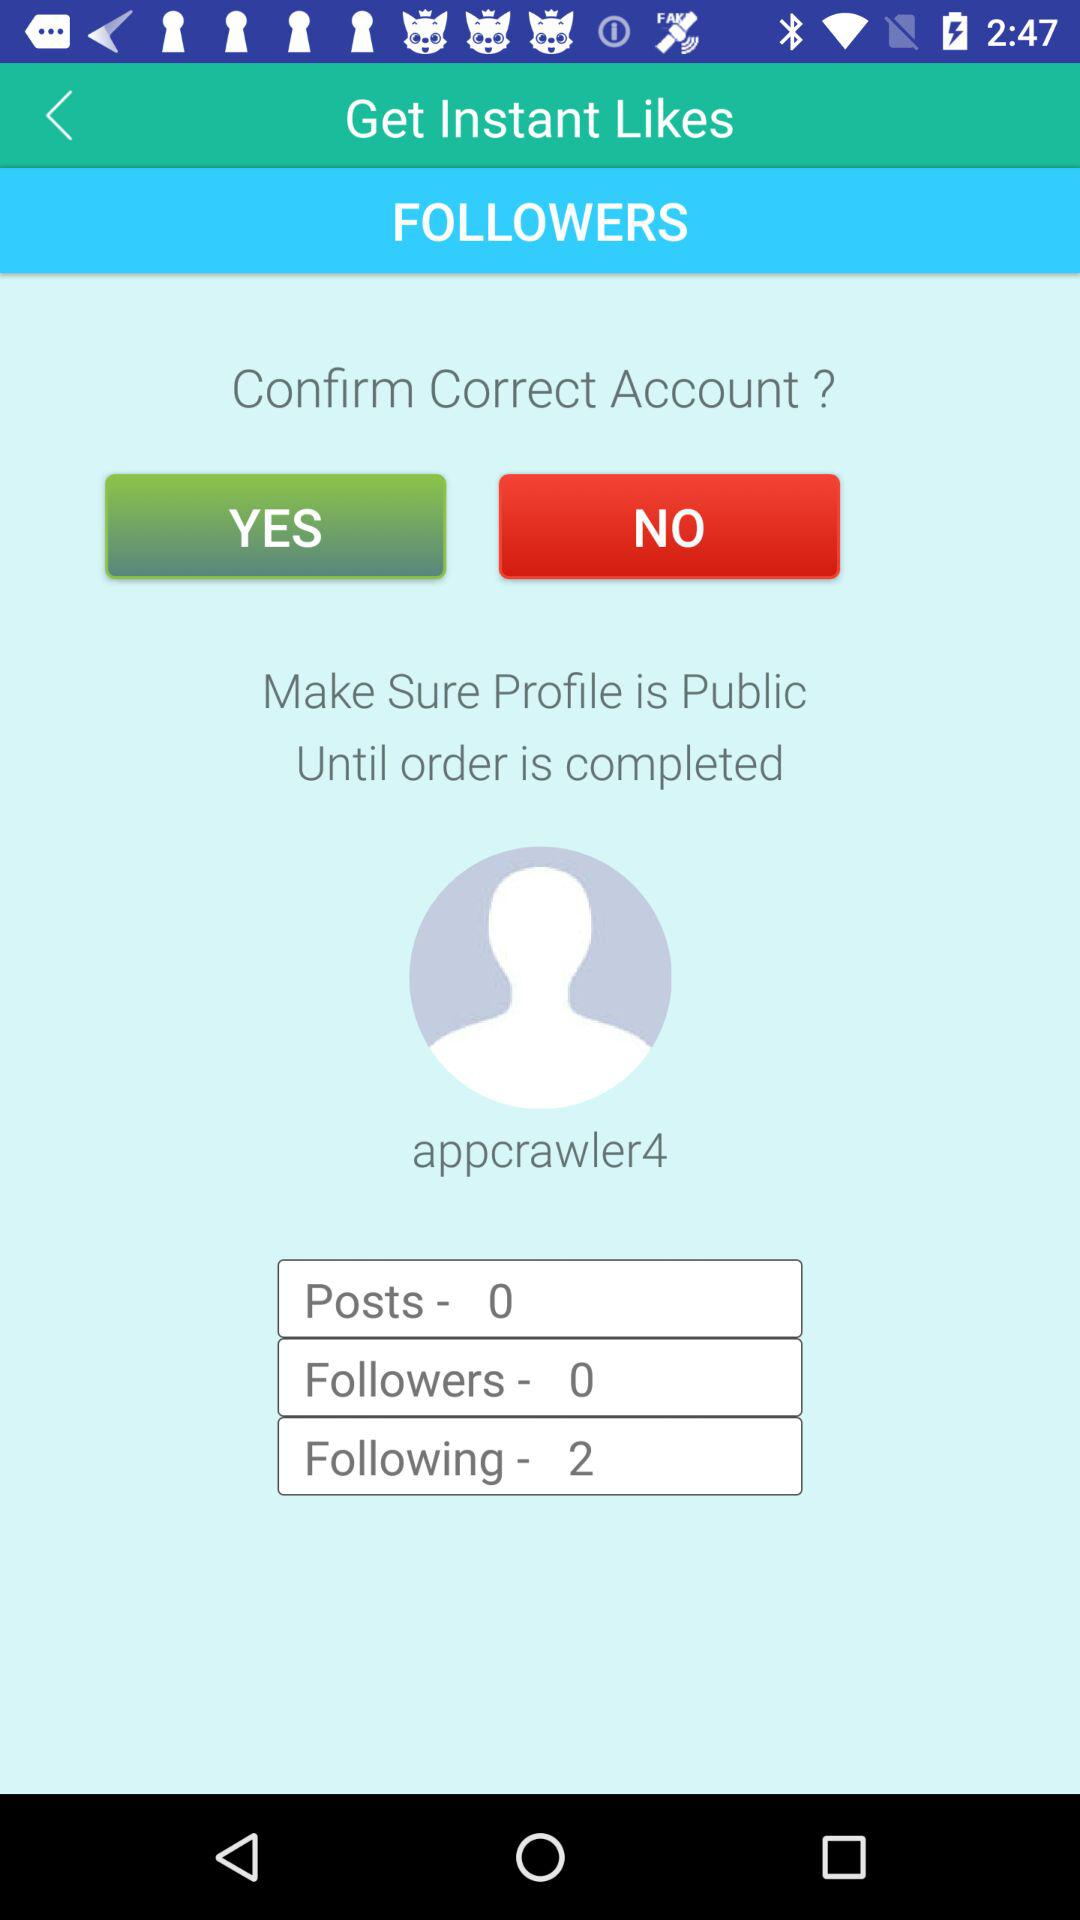How many more people is the user following than they have followers?
Answer the question using a single word or phrase. 2 